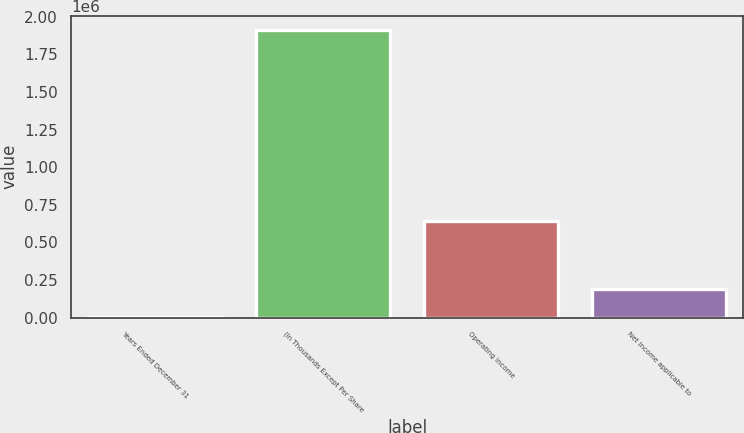<chart> <loc_0><loc_0><loc_500><loc_500><bar_chart><fcel>Years Ended December 31<fcel>(In Thousands Except Per Share<fcel>Operating income<fcel>Net income applicable to<nl><fcel>2002<fcel>1.91046e+06<fcel>640137<fcel>192848<nl></chart> 